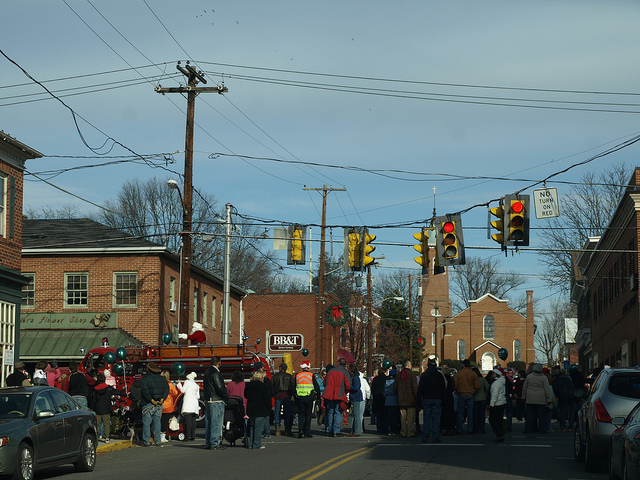Read and extract the text from this image. BR&T NO TURN ON RED 